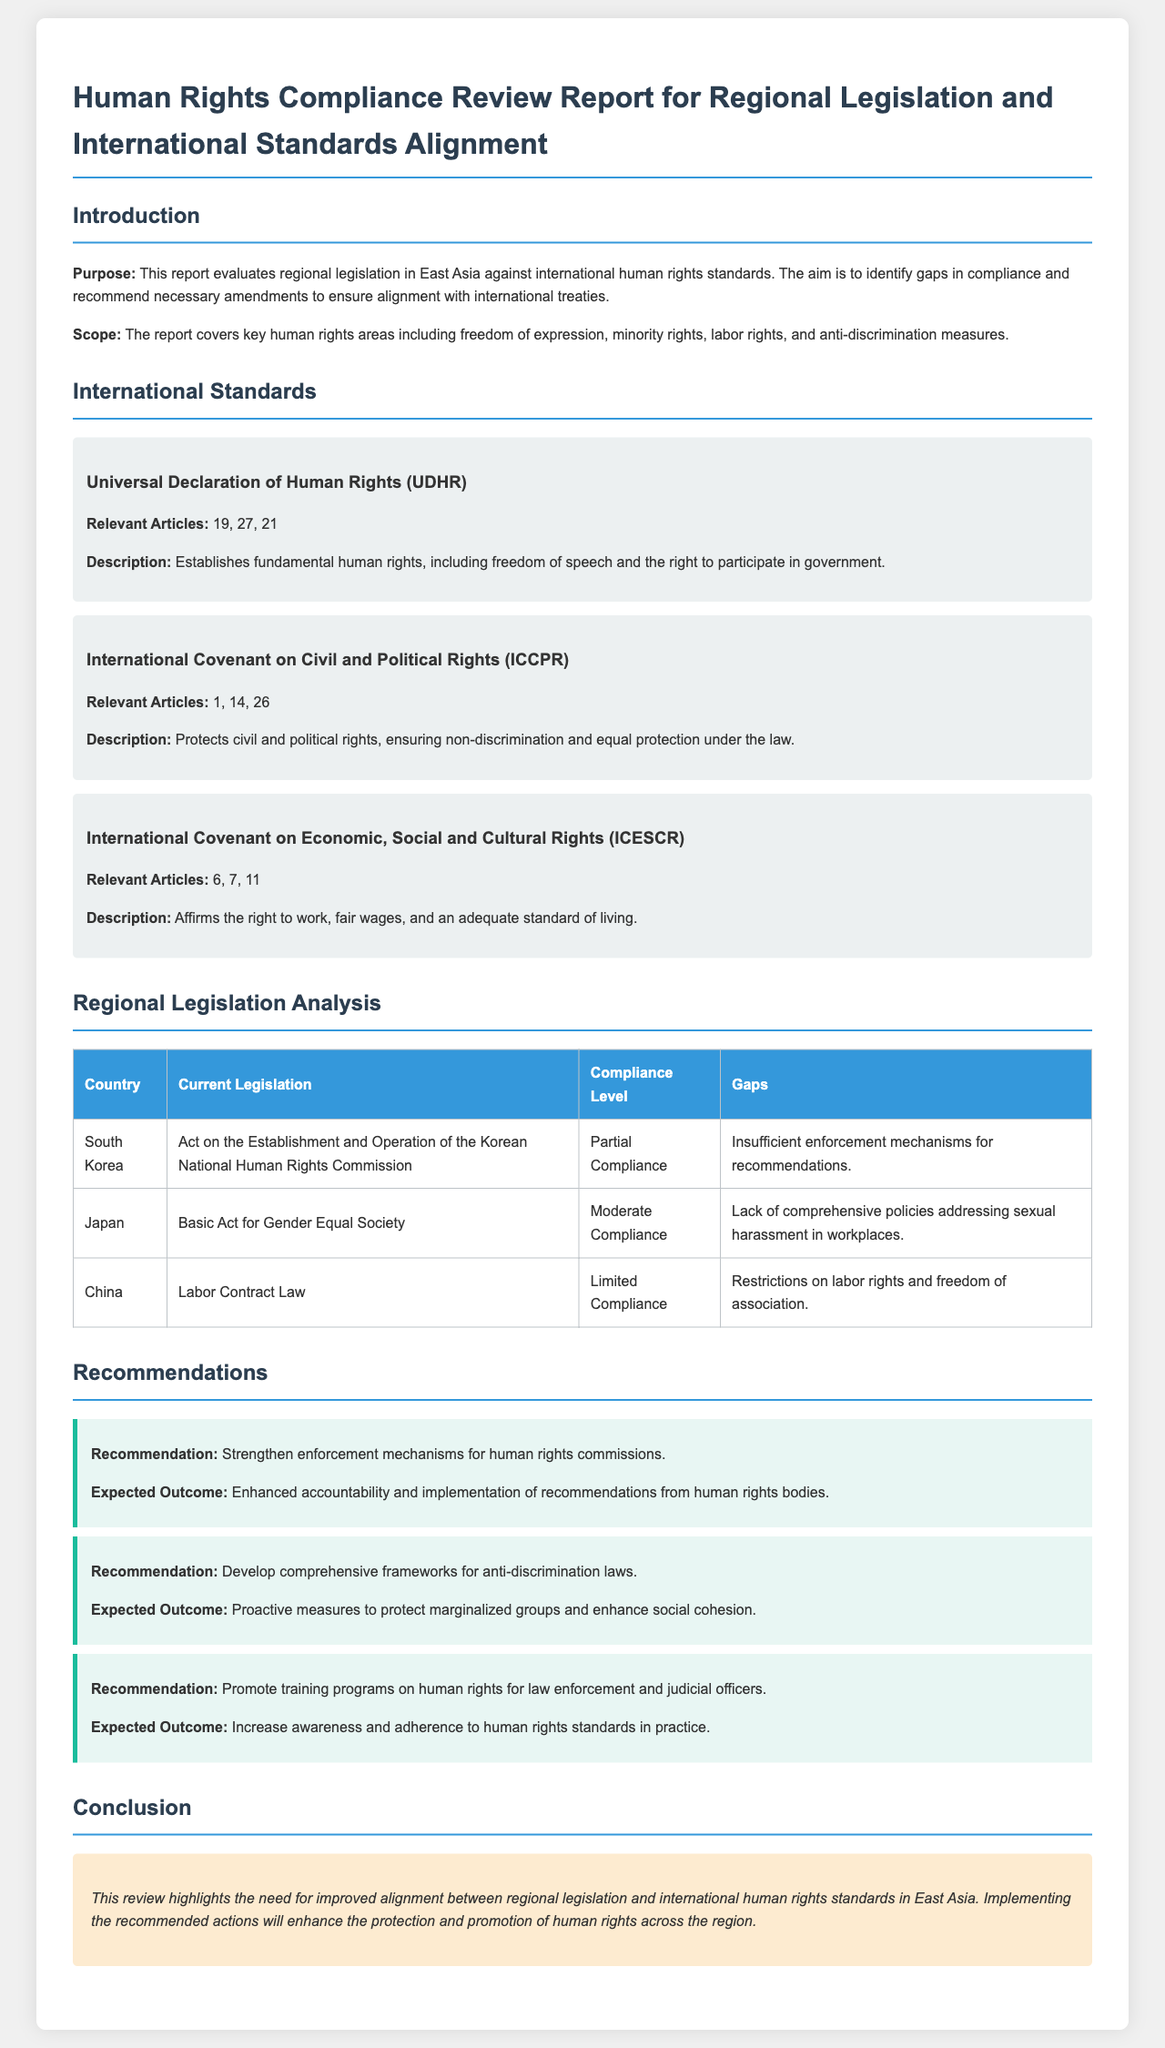what is the purpose of the report? The purpose of the report is to evaluate regional legislation in East Asia against international human rights standards to identify gaps in compliance and recommend necessary amendments.
Answer: evaluate regional legislation which international document protects civil and political rights? The document identifies the International Covenant on Civil and Political Rights as the one that protects civil and political rights.
Answer: International Covenant on Civil and Political Rights what is the compliance level of Japan's legislation? The compliance level of Japan's legislation, as stated in the report, is moderate.
Answer: Moderate Compliance what gap is identified in South Korea's legislation? Insufficient enforcement mechanisms for recommendations is stated as the gap in South Korea's legislation.
Answer: Insufficient enforcement mechanisms what is one recommendation provided in the report? The report recommends strengthening enforcement mechanisms for human rights commissions.
Answer: Strengthen enforcement mechanisms what expected outcome is associated with developing comprehensive frameworks for anti-discrimination laws? The expected outcome noted for developing comprehensive frameworks for anti-discrimination laws is proactive measures to protect marginalized groups.
Answer: Proactive measures to protect marginalized groups which article of the UDHR pertains to freedom of speech? Article 19 of the UDHR pertains to freedom of speech, as mentioned in the report.
Answer: 19 what region is the focus of the human rights compliance review? The focus of the human rights compliance review is on East Asia.
Answer: East Asia 